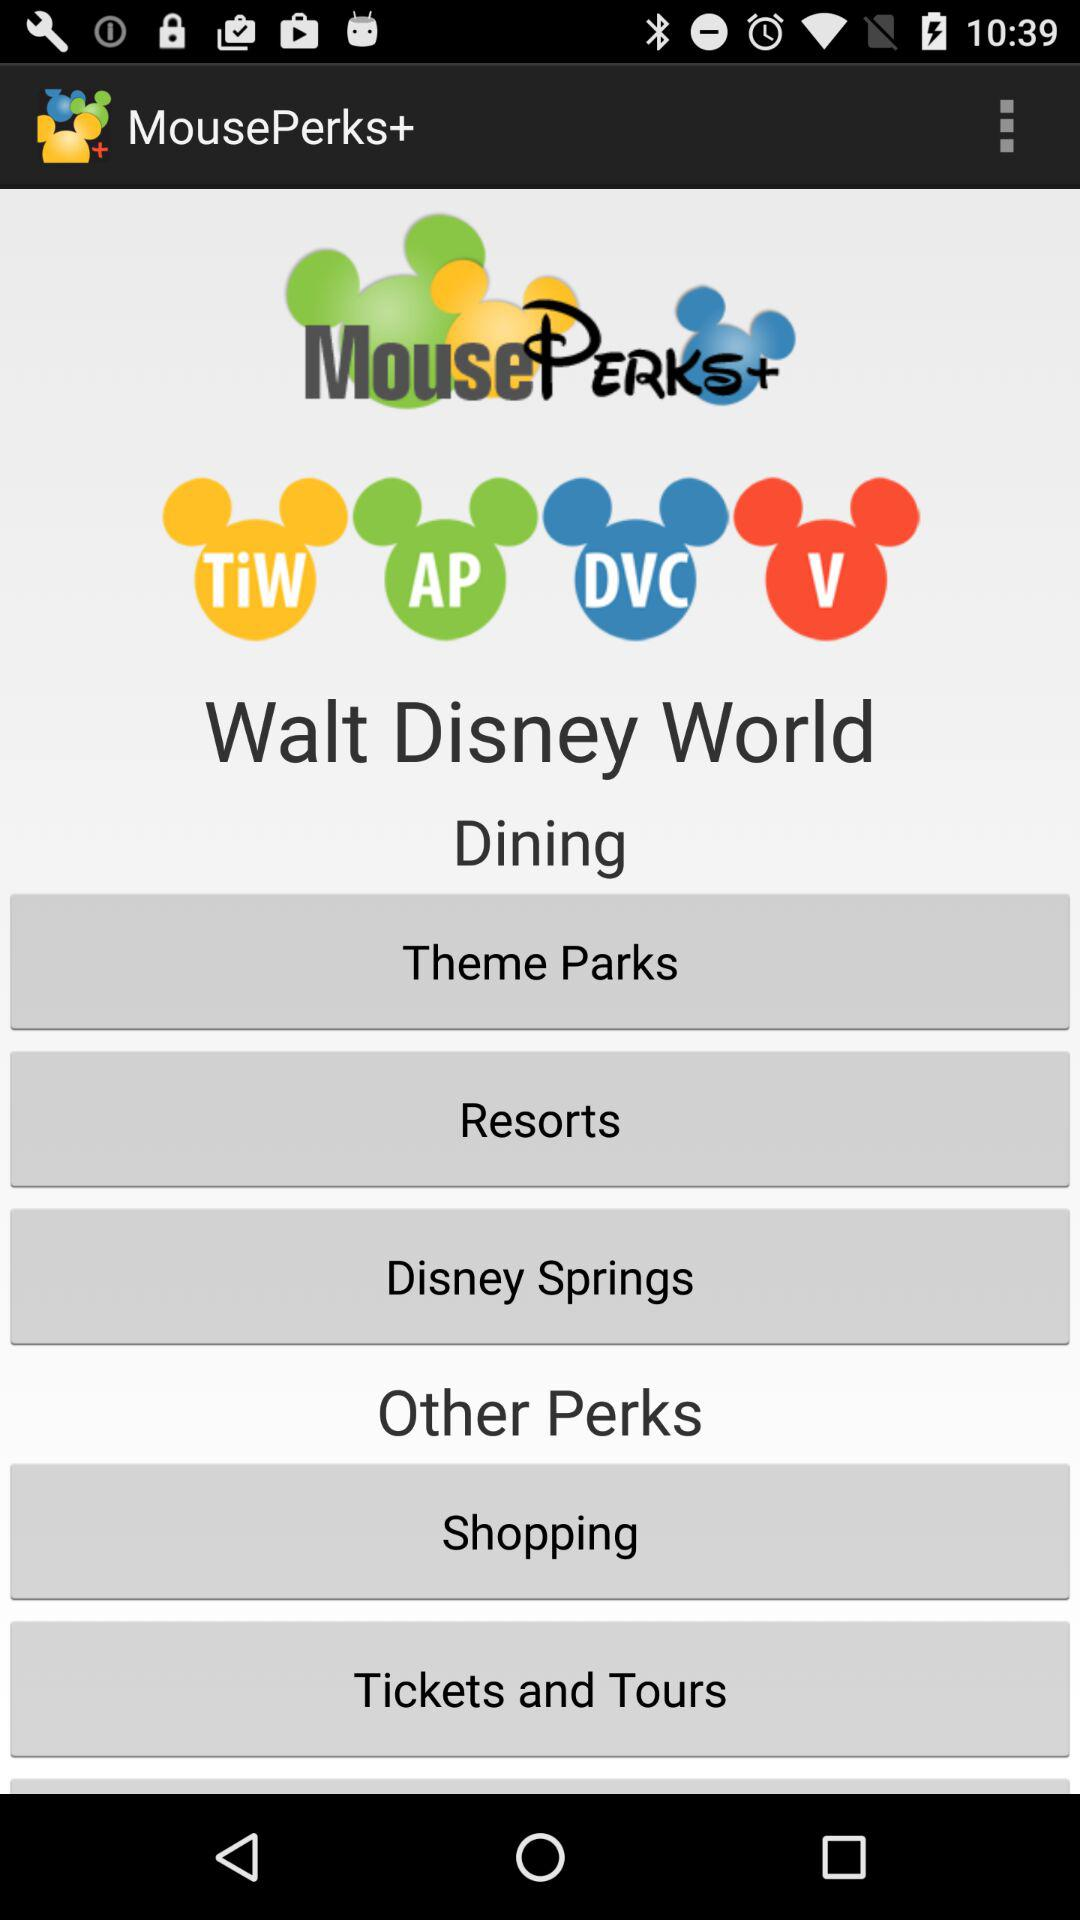What is the name of the application? The name of the application is "MousePerks+". 